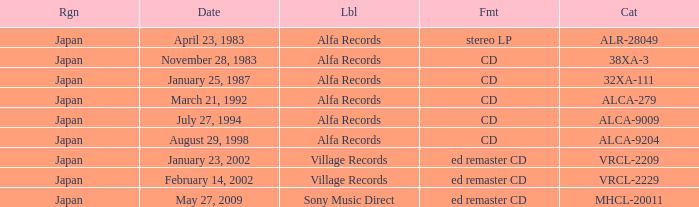Which date is in stereo lp format? April 23, 1983. 